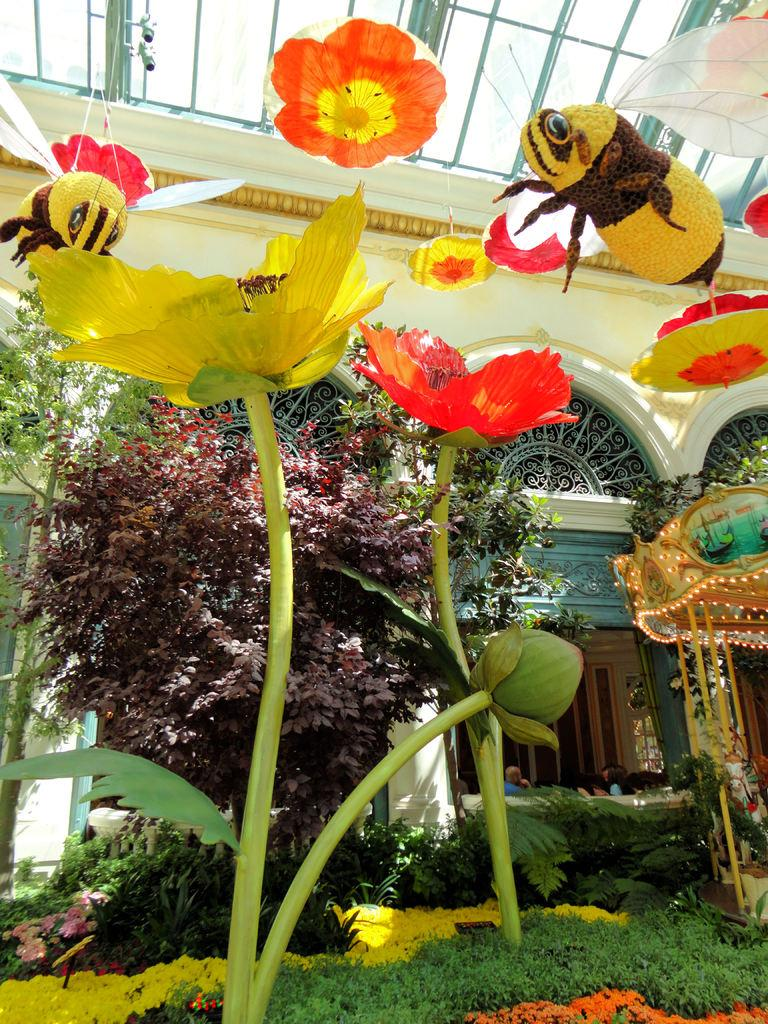What is located in the middle of the image? There are trees, a building, and flowers in the middle of the image. Can you describe the building in the image? The building in the image is located in the middle, surrounded by trees and flowers. What type of vegetation can be seen in the image? Trees and flowers are visible in the image. What advice does the father give to the person in the image? There is no father or person present in the image, so it is not possible to answer that question. 